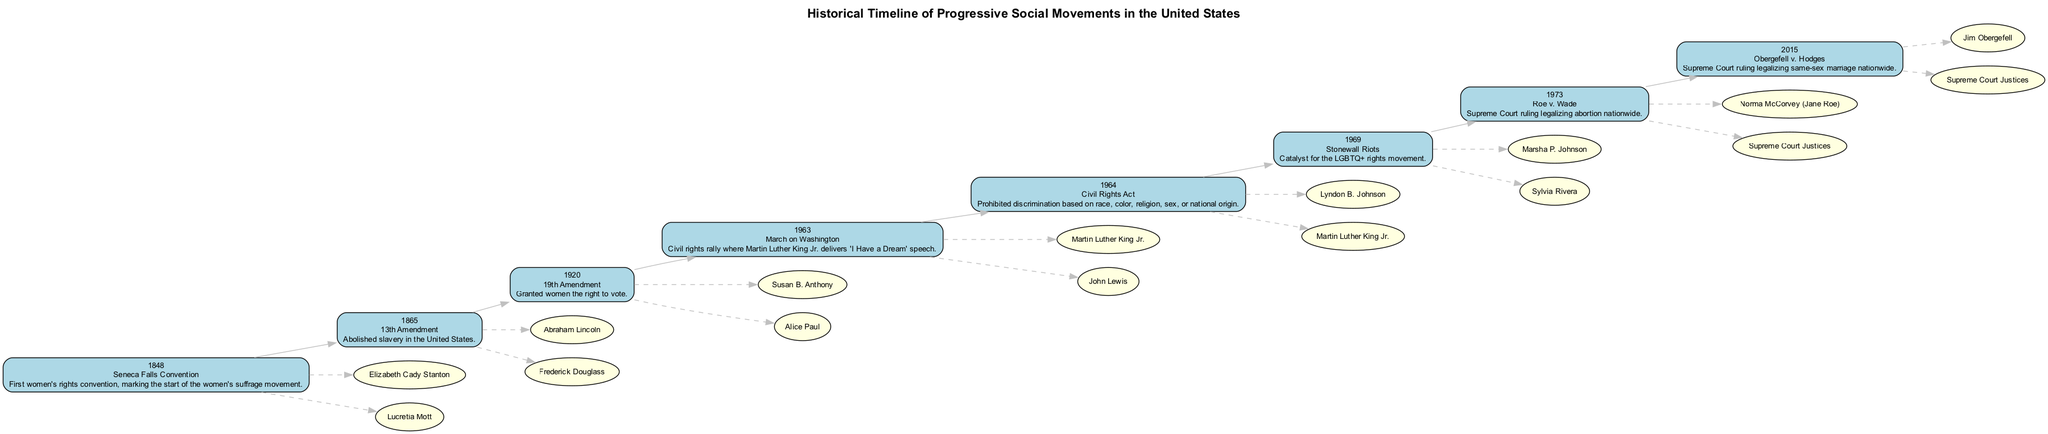What event marked the start of the women's suffrage movement? The diagram shows the event "Seneca Falls Convention" in 1848, which is described as the first women's rights convention and the start of the women's suffrage movement.
Answer: Seneca Falls Convention Who were key figures in the civil rights movement represented in 1963? The event "March on Washington" in 1963 lists key figures as "Martin Luther King Jr." and "John Lewis," highlighting their importance in this pivotal civil rights rally.
Answer: Martin Luther King Jr., John Lewis What landmark Supreme Court ruling occurred in 1973? The diagram notes the event "Roe v. Wade" in 1973, indicating it was a significant Supreme Court ruling regarding abortion legality.
Answer: Roe v. Wade How many key figures are associated with the "Stonewall Riots"? The "Stonewall Riots" in 1969 lists two key figures: "Marsha P. Johnson" and "Sylvia Rivera." Therefore, there are two key figures associated with this event.
Answer: 2 Which event is directly before the legalization of same-sex marriage in 2015? The timeline shows "Obergefell v. Hodges" in 2015, and the previous event on the timeline is "Roe v. Wade" in 1973. Therefore, "Roe v. Wade" directly precedes "Obergefell v. Hodges."
Answer: Roe v. Wade Who was a key figure in the 19th Amendment? The event "19th Amendment" in 1920 lists "Susan B. Anthony" and "Alice Paul" as key figures, with either being correct; however, only one name is needed.
Answer: Susan B. Anthony What major social issue did the Civil Rights Act of 1964 address? The "Civil Rights Act" in 1964 is described as prohibiting discrimination based on race, color, religion, sex, or national origin, indicating its focus on civil rights issues.
Answer: Discrimination How many events are listed on the timeline? The timeline has eight events documented (from 1848 to 2015), representing notable progressive social movements in U.S. history.
Answer: 8 Which two movements are connected by the 13th Amendment in 1865? The timeline outlines that the 13th Amendment abolished slavery, making a connection to the broader movements for racial equality and civil rights following this legislative milestone.
Answer: Racial equality and civil rights 